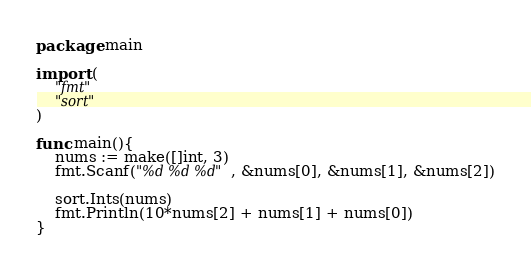<code> <loc_0><loc_0><loc_500><loc_500><_Go_>package main

import (
    "fmt"
    "sort"
)    

func main(){
    nums := make([]int, 3)
    fmt.Scanf("%d %d %d", &nums[0], &nums[1], &nums[2])
    
    sort.Ints(nums)
    fmt.Println(10*nums[2] + nums[1] + nums[0])
}
</code> 